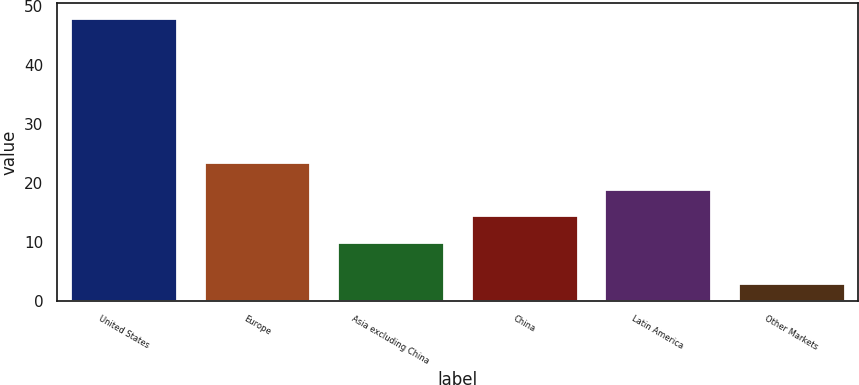Convert chart. <chart><loc_0><loc_0><loc_500><loc_500><bar_chart><fcel>United States<fcel>Europe<fcel>Asia excluding China<fcel>China<fcel>Latin America<fcel>Other Markets<nl><fcel>48<fcel>23.5<fcel>10<fcel>14.5<fcel>19<fcel>3<nl></chart> 